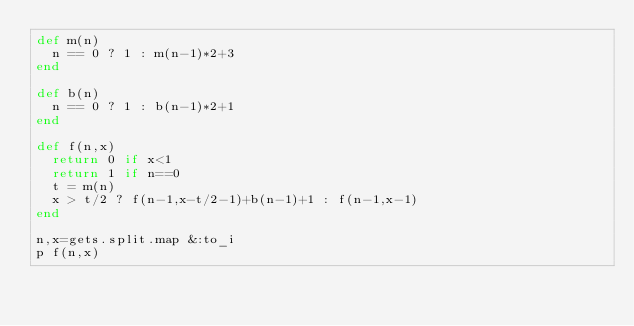Convert code to text. <code><loc_0><loc_0><loc_500><loc_500><_Ruby_>def m(n)
  n == 0 ? 1 : m(n-1)*2+3
end

def b(n)
  n == 0 ? 1 : b(n-1)*2+1
end

def f(n,x)
  return 0 if x<1
  return 1 if n==0
  t = m(n)
  x > t/2 ? f(n-1,x-t/2-1)+b(n-1)+1 : f(n-1,x-1)
end

n,x=gets.split.map &:to_i
p f(n,x)</code> 